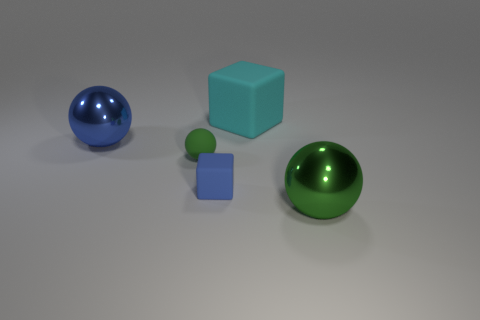Subtract all large spheres. How many spheres are left? 1 Subtract all yellow cylinders. How many green balls are left? 2 Add 4 green rubber cubes. How many objects exist? 9 Subtract all blue spheres. How many spheres are left? 2 Subtract all gray spheres. Subtract all green cylinders. How many spheres are left? 3 Add 5 small objects. How many small objects are left? 7 Add 1 brown metal cubes. How many brown metal cubes exist? 1 Subtract 0 green blocks. How many objects are left? 5 Subtract all blocks. How many objects are left? 3 Subtract all spheres. Subtract all big metal spheres. How many objects are left? 0 